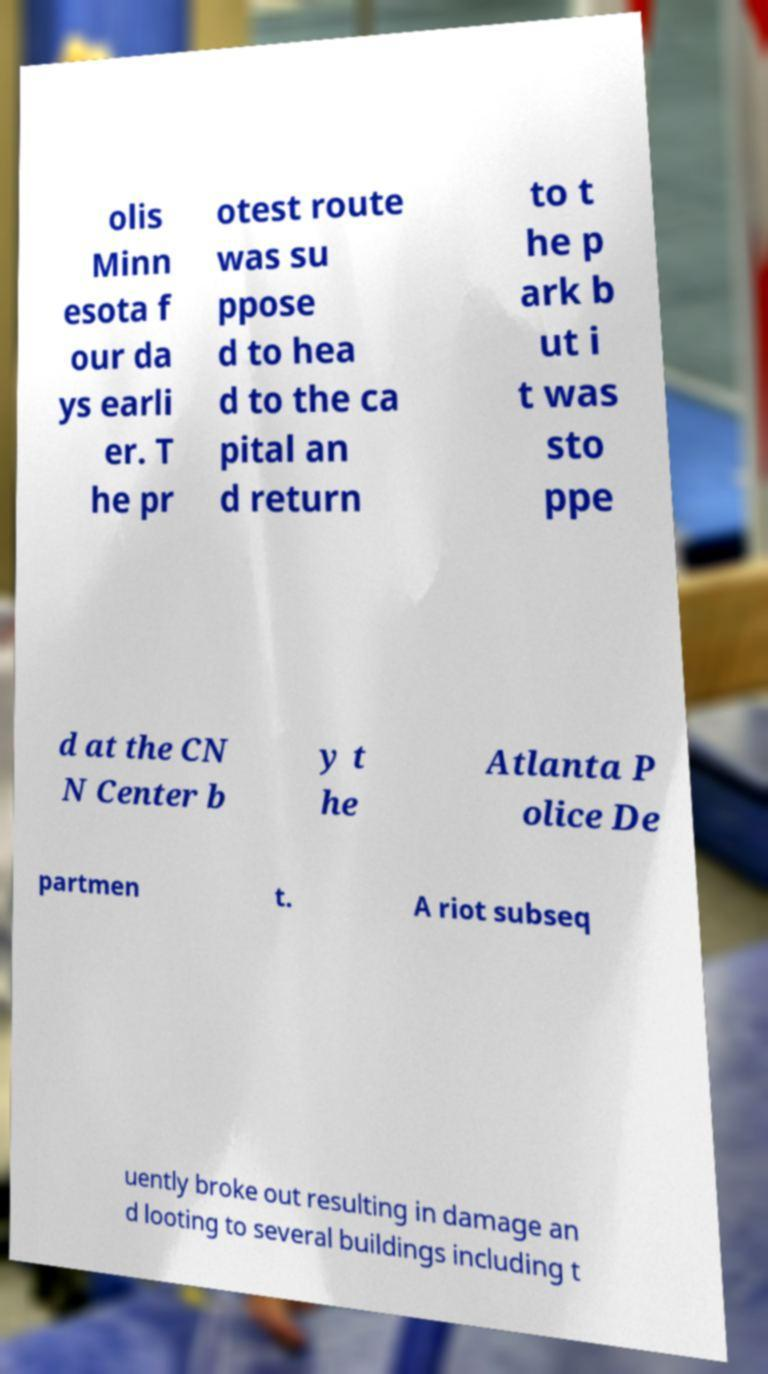Can you accurately transcribe the text from the provided image for me? olis Minn esota f our da ys earli er. T he pr otest route was su ppose d to hea d to the ca pital an d return to t he p ark b ut i t was sto ppe d at the CN N Center b y t he Atlanta P olice De partmen t. A riot subseq uently broke out resulting in damage an d looting to several buildings including t 